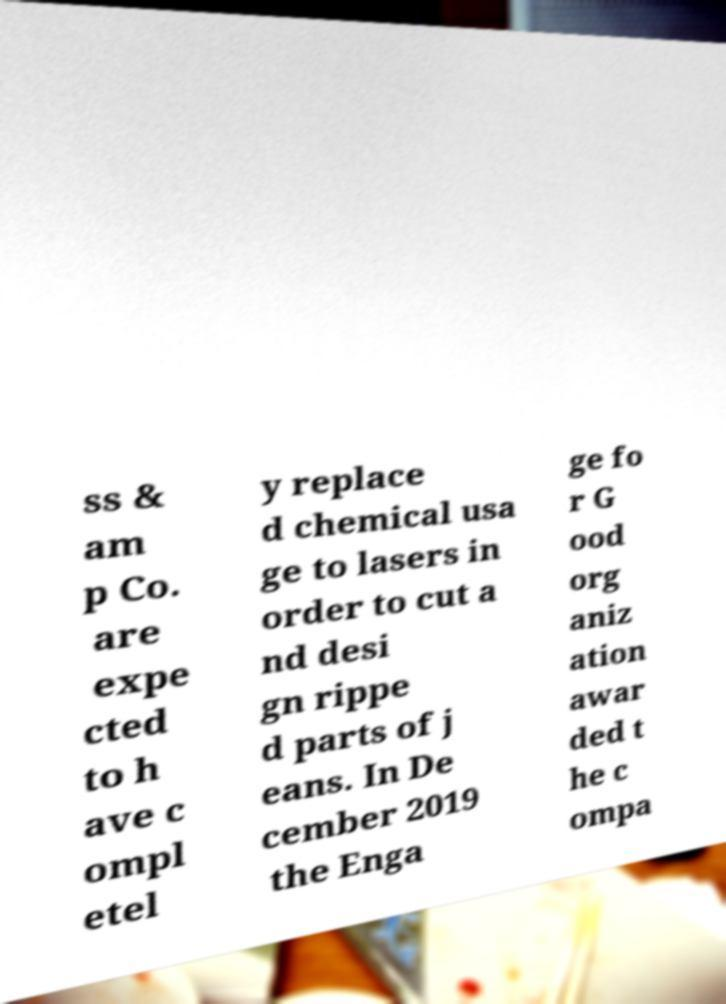Can you read and provide the text displayed in the image?This photo seems to have some interesting text. Can you extract and type it out for me? ss & am p Co. are expe cted to h ave c ompl etel y replace d chemical usa ge to lasers in order to cut a nd desi gn rippe d parts of j eans. In De cember 2019 the Enga ge fo r G ood org aniz ation awar ded t he c ompa 